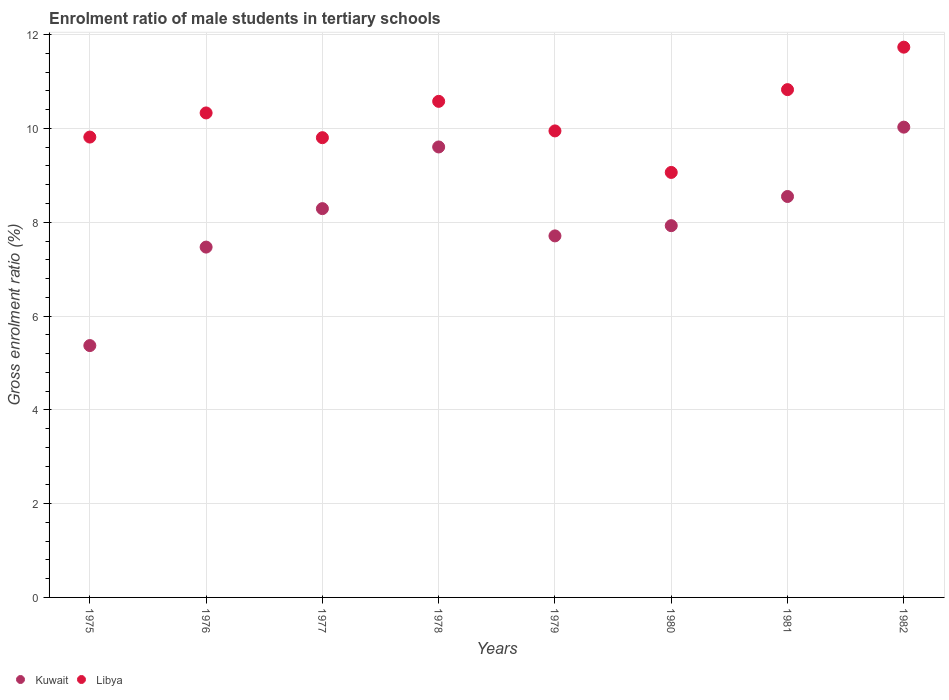How many different coloured dotlines are there?
Your answer should be very brief. 2. Is the number of dotlines equal to the number of legend labels?
Offer a terse response. Yes. What is the enrolment ratio of male students in tertiary schools in Kuwait in 1975?
Offer a terse response. 5.37. Across all years, what is the maximum enrolment ratio of male students in tertiary schools in Libya?
Offer a terse response. 11.73. Across all years, what is the minimum enrolment ratio of male students in tertiary schools in Kuwait?
Give a very brief answer. 5.37. What is the total enrolment ratio of male students in tertiary schools in Libya in the graph?
Offer a very short reply. 82.1. What is the difference between the enrolment ratio of male students in tertiary schools in Kuwait in 1977 and that in 1979?
Your answer should be compact. 0.58. What is the difference between the enrolment ratio of male students in tertiary schools in Libya in 1979 and the enrolment ratio of male students in tertiary schools in Kuwait in 1975?
Make the answer very short. 4.58. What is the average enrolment ratio of male students in tertiary schools in Libya per year?
Offer a very short reply. 10.26. In the year 1976, what is the difference between the enrolment ratio of male students in tertiary schools in Libya and enrolment ratio of male students in tertiary schools in Kuwait?
Offer a very short reply. 2.86. What is the ratio of the enrolment ratio of male students in tertiary schools in Libya in 1979 to that in 1980?
Make the answer very short. 1.1. Is the difference between the enrolment ratio of male students in tertiary schools in Libya in 1977 and 1978 greater than the difference between the enrolment ratio of male students in tertiary schools in Kuwait in 1977 and 1978?
Offer a very short reply. Yes. What is the difference between the highest and the second highest enrolment ratio of male students in tertiary schools in Libya?
Provide a succinct answer. 0.91. What is the difference between the highest and the lowest enrolment ratio of male students in tertiary schools in Libya?
Your answer should be very brief. 2.67. Is the sum of the enrolment ratio of male students in tertiary schools in Kuwait in 1981 and 1982 greater than the maximum enrolment ratio of male students in tertiary schools in Libya across all years?
Provide a short and direct response. Yes. Does the enrolment ratio of male students in tertiary schools in Libya monotonically increase over the years?
Give a very brief answer. No. Is the enrolment ratio of male students in tertiary schools in Kuwait strictly less than the enrolment ratio of male students in tertiary schools in Libya over the years?
Ensure brevity in your answer.  Yes. How many dotlines are there?
Keep it short and to the point. 2. What is the difference between two consecutive major ticks on the Y-axis?
Your response must be concise. 2. Are the values on the major ticks of Y-axis written in scientific E-notation?
Make the answer very short. No. Does the graph contain grids?
Offer a terse response. Yes. Where does the legend appear in the graph?
Keep it short and to the point. Bottom left. How many legend labels are there?
Ensure brevity in your answer.  2. What is the title of the graph?
Ensure brevity in your answer.  Enrolment ratio of male students in tertiary schools. What is the label or title of the Y-axis?
Offer a very short reply. Gross enrolment ratio (%). What is the Gross enrolment ratio (%) in Kuwait in 1975?
Ensure brevity in your answer.  5.37. What is the Gross enrolment ratio (%) in Libya in 1975?
Make the answer very short. 9.82. What is the Gross enrolment ratio (%) of Kuwait in 1976?
Offer a terse response. 7.47. What is the Gross enrolment ratio (%) in Libya in 1976?
Ensure brevity in your answer.  10.33. What is the Gross enrolment ratio (%) in Kuwait in 1977?
Give a very brief answer. 8.29. What is the Gross enrolment ratio (%) of Libya in 1977?
Provide a short and direct response. 9.8. What is the Gross enrolment ratio (%) of Kuwait in 1978?
Offer a terse response. 9.61. What is the Gross enrolment ratio (%) of Libya in 1978?
Give a very brief answer. 10.58. What is the Gross enrolment ratio (%) of Kuwait in 1979?
Provide a short and direct response. 7.71. What is the Gross enrolment ratio (%) of Libya in 1979?
Offer a very short reply. 9.95. What is the Gross enrolment ratio (%) of Kuwait in 1980?
Make the answer very short. 7.93. What is the Gross enrolment ratio (%) in Libya in 1980?
Offer a very short reply. 9.06. What is the Gross enrolment ratio (%) in Kuwait in 1981?
Offer a terse response. 8.55. What is the Gross enrolment ratio (%) in Libya in 1981?
Your answer should be very brief. 10.83. What is the Gross enrolment ratio (%) of Kuwait in 1982?
Your response must be concise. 10.03. What is the Gross enrolment ratio (%) in Libya in 1982?
Offer a terse response. 11.73. Across all years, what is the maximum Gross enrolment ratio (%) of Kuwait?
Give a very brief answer. 10.03. Across all years, what is the maximum Gross enrolment ratio (%) of Libya?
Provide a short and direct response. 11.73. Across all years, what is the minimum Gross enrolment ratio (%) in Kuwait?
Provide a short and direct response. 5.37. Across all years, what is the minimum Gross enrolment ratio (%) of Libya?
Offer a terse response. 9.06. What is the total Gross enrolment ratio (%) in Kuwait in the graph?
Your answer should be very brief. 64.95. What is the total Gross enrolment ratio (%) in Libya in the graph?
Your answer should be compact. 82.1. What is the difference between the Gross enrolment ratio (%) in Kuwait in 1975 and that in 1976?
Offer a terse response. -2.1. What is the difference between the Gross enrolment ratio (%) in Libya in 1975 and that in 1976?
Offer a very short reply. -0.51. What is the difference between the Gross enrolment ratio (%) in Kuwait in 1975 and that in 1977?
Provide a short and direct response. -2.92. What is the difference between the Gross enrolment ratio (%) of Libya in 1975 and that in 1977?
Make the answer very short. 0.01. What is the difference between the Gross enrolment ratio (%) in Kuwait in 1975 and that in 1978?
Give a very brief answer. -4.24. What is the difference between the Gross enrolment ratio (%) of Libya in 1975 and that in 1978?
Keep it short and to the point. -0.76. What is the difference between the Gross enrolment ratio (%) of Kuwait in 1975 and that in 1979?
Provide a succinct answer. -2.34. What is the difference between the Gross enrolment ratio (%) in Libya in 1975 and that in 1979?
Offer a terse response. -0.13. What is the difference between the Gross enrolment ratio (%) of Kuwait in 1975 and that in 1980?
Give a very brief answer. -2.56. What is the difference between the Gross enrolment ratio (%) of Libya in 1975 and that in 1980?
Offer a terse response. 0.75. What is the difference between the Gross enrolment ratio (%) of Kuwait in 1975 and that in 1981?
Ensure brevity in your answer.  -3.18. What is the difference between the Gross enrolment ratio (%) in Libya in 1975 and that in 1981?
Give a very brief answer. -1.01. What is the difference between the Gross enrolment ratio (%) in Kuwait in 1975 and that in 1982?
Keep it short and to the point. -4.66. What is the difference between the Gross enrolment ratio (%) in Libya in 1975 and that in 1982?
Your answer should be compact. -1.92. What is the difference between the Gross enrolment ratio (%) of Kuwait in 1976 and that in 1977?
Provide a short and direct response. -0.82. What is the difference between the Gross enrolment ratio (%) in Libya in 1976 and that in 1977?
Keep it short and to the point. 0.53. What is the difference between the Gross enrolment ratio (%) in Kuwait in 1976 and that in 1978?
Your response must be concise. -2.14. What is the difference between the Gross enrolment ratio (%) in Libya in 1976 and that in 1978?
Keep it short and to the point. -0.25. What is the difference between the Gross enrolment ratio (%) of Kuwait in 1976 and that in 1979?
Your response must be concise. -0.24. What is the difference between the Gross enrolment ratio (%) of Libya in 1976 and that in 1979?
Keep it short and to the point. 0.38. What is the difference between the Gross enrolment ratio (%) in Kuwait in 1976 and that in 1980?
Your answer should be very brief. -0.46. What is the difference between the Gross enrolment ratio (%) of Libya in 1976 and that in 1980?
Provide a short and direct response. 1.27. What is the difference between the Gross enrolment ratio (%) in Kuwait in 1976 and that in 1981?
Your response must be concise. -1.08. What is the difference between the Gross enrolment ratio (%) of Libya in 1976 and that in 1981?
Your answer should be very brief. -0.5. What is the difference between the Gross enrolment ratio (%) in Kuwait in 1976 and that in 1982?
Your answer should be compact. -2.56. What is the difference between the Gross enrolment ratio (%) of Libya in 1976 and that in 1982?
Your response must be concise. -1.4. What is the difference between the Gross enrolment ratio (%) of Kuwait in 1977 and that in 1978?
Offer a terse response. -1.32. What is the difference between the Gross enrolment ratio (%) of Libya in 1977 and that in 1978?
Offer a terse response. -0.77. What is the difference between the Gross enrolment ratio (%) in Kuwait in 1977 and that in 1979?
Offer a very short reply. 0.58. What is the difference between the Gross enrolment ratio (%) of Libya in 1977 and that in 1979?
Provide a short and direct response. -0.14. What is the difference between the Gross enrolment ratio (%) of Kuwait in 1977 and that in 1980?
Make the answer very short. 0.36. What is the difference between the Gross enrolment ratio (%) in Libya in 1977 and that in 1980?
Ensure brevity in your answer.  0.74. What is the difference between the Gross enrolment ratio (%) of Kuwait in 1977 and that in 1981?
Make the answer very short. -0.26. What is the difference between the Gross enrolment ratio (%) in Libya in 1977 and that in 1981?
Ensure brevity in your answer.  -1.02. What is the difference between the Gross enrolment ratio (%) of Kuwait in 1977 and that in 1982?
Give a very brief answer. -1.74. What is the difference between the Gross enrolment ratio (%) in Libya in 1977 and that in 1982?
Your answer should be compact. -1.93. What is the difference between the Gross enrolment ratio (%) in Kuwait in 1978 and that in 1979?
Your response must be concise. 1.9. What is the difference between the Gross enrolment ratio (%) of Libya in 1978 and that in 1979?
Offer a very short reply. 0.63. What is the difference between the Gross enrolment ratio (%) of Kuwait in 1978 and that in 1980?
Your response must be concise. 1.68. What is the difference between the Gross enrolment ratio (%) of Libya in 1978 and that in 1980?
Keep it short and to the point. 1.52. What is the difference between the Gross enrolment ratio (%) of Kuwait in 1978 and that in 1981?
Your answer should be very brief. 1.06. What is the difference between the Gross enrolment ratio (%) in Libya in 1978 and that in 1981?
Ensure brevity in your answer.  -0.25. What is the difference between the Gross enrolment ratio (%) in Kuwait in 1978 and that in 1982?
Offer a very short reply. -0.42. What is the difference between the Gross enrolment ratio (%) in Libya in 1978 and that in 1982?
Provide a short and direct response. -1.16. What is the difference between the Gross enrolment ratio (%) of Kuwait in 1979 and that in 1980?
Your response must be concise. -0.22. What is the difference between the Gross enrolment ratio (%) of Libya in 1979 and that in 1980?
Your answer should be compact. 0.89. What is the difference between the Gross enrolment ratio (%) in Kuwait in 1979 and that in 1981?
Your answer should be compact. -0.84. What is the difference between the Gross enrolment ratio (%) in Libya in 1979 and that in 1981?
Keep it short and to the point. -0.88. What is the difference between the Gross enrolment ratio (%) in Kuwait in 1979 and that in 1982?
Your answer should be compact. -2.32. What is the difference between the Gross enrolment ratio (%) of Libya in 1979 and that in 1982?
Provide a short and direct response. -1.79. What is the difference between the Gross enrolment ratio (%) of Kuwait in 1980 and that in 1981?
Your answer should be very brief. -0.62. What is the difference between the Gross enrolment ratio (%) of Libya in 1980 and that in 1981?
Give a very brief answer. -1.77. What is the difference between the Gross enrolment ratio (%) of Kuwait in 1980 and that in 1982?
Provide a succinct answer. -2.1. What is the difference between the Gross enrolment ratio (%) in Libya in 1980 and that in 1982?
Ensure brevity in your answer.  -2.67. What is the difference between the Gross enrolment ratio (%) in Kuwait in 1981 and that in 1982?
Offer a terse response. -1.48. What is the difference between the Gross enrolment ratio (%) of Libya in 1981 and that in 1982?
Your answer should be very brief. -0.91. What is the difference between the Gross enrolment ratio (%) in Kuwait in 1975 and the Gross enrolment ratio (%) in Libya in 1976?
Your response must be concise. -4.96. What is the difference between the Gross enrolment ratio (%) of Kuwait in 1975 and the Gross enrolment ratio (%) of Libya in 1977?
Ensure brevity in your answer.  -4.43. What is the difference between the Gross enrolment ratio (%) of Kuwait in 1975 and the Gross enrolment ratio (%) of Libya in 1978?
Make the answer very short. -5.21. What is the difference between the Gross enrolment ratio (%) in Kuwait in 1975 and the Gross enrolment ratio (%) in Libya in 1979?
Your response must be concise. -4.58. What is the difference between the Gross enrolment ratio (%) in Kuwait in 1975 and the Gross enrolment ratio (%) in Libya in 1980?
Ensure brevity in your answer.  -3.69. What is the difference between the Gross enrolment ratio (%) of Kuwait in 1975 and the Gross enrolment ratio (%) of Libya in 1981?
Provide a succinct answer. -5.46. What is the difference between the Gross enrolment ratio (%) of Kuwait in 1975 and the Gross enrolment ratio (%) of Libya in 1982?
Make the answer very short. -6.36. What is the difference between the Gross enrolment ratio (%) of Kuwait in 1976 and the Gross enrolment ratio (%) of Libya in 1977?
Your answer should be compact. -2.33. What is the difference between the Gross enrolment ratio (%) of Kuwait in 1976 and the Gross enrolment ratio (%) of Libya in 1978?
Make the answer very short. -3.11. What is the difference between the Gross enrolment ratio (%) in Kuwait in 1976 and the Gross enrolment ratio (%) in Libya in 1979?
Keep it short and to the point. -2.48. What is the difference between the Gross enrolment ratio (%) of Kuwait in 1976 and the Gross enrolment ratio (%) of Libya in 1980?
Offer a terse response. -1.59. What is the difference between the Gross enrolment ratio (%) of Kuwait in 1976 and the Gross enrolment ratio (%) of Libya in 1981?
Make the answer very short. -3.36. What is the difference between the Gross enrolment ratio (%) of Kuwait in 1976 and the Gross enrolment ratio (%) of Libya in 1982?
Keep it short and to the point. -4.26. What is the difference between the Gross enrolment ratio (%) of Kuwait in 1977 and the Gross enrolment ratio (%) of Libya in 1978?
Give a very brief answer. -2.29. What is the difference between the Gross enrolment ratio (%) of Kuwait in 1977 and the Gross enrolment ratio (%) of Libya in 1979?
Keep it short and to the point. -1.66. What is the difference between the Gross enrolment ratio (%) in Kuwait in 1977 and the Gross enrolment ratio (%) in Libya in 1980?
Provide a short and direct response. -0.77. What is the difference between the Gross enrolment ratio (%) of Kuwait in 1977 and the Gross enrolment ratio (%) of Libya in 1981?
Offer a very short reply. -2.54. What is the difference between the Gross enrolment ratio (%) of Kuwait in 1977 and the Gross enrolment ratio (%) of Libya in 1982?
Keep it short and to the point. -3.44. What is the difference between the Gross enrolment ratio (%) in Kuwait in 1978 and the Gross enrolment ratio (%) in Libya in 1979?
Make the answer very short. -0.34. What is the difference between the Gross enrolment ratio (%) in Kuwait in 1978 and the Gross enrolment ratio (%) in Libya in 1980?
Your answer should be compact. 0.54. What is the difference between the Gross enrolment ratio (%) in Kuwait in 1978 and the Gross enrolment ratio (%) in Libya in 1981?
Make the answer very short. -1.22. What is the difference between the Gross enrolment ratio (%) of Kuwait in 1978 and the Gross enrolment ratio (%) of Libya in 1982?
Your answer should be very brief. -2.13. What is the difference between the Gross enrolment ratio (%) of Kuwait in 1979 and the Gross enrolment ratio (%) of Libya in 1980?
Your answer should be compact. -1.35. What is the difference between the Gross enrolment ratio (%) in Kuwait in 1979 and the Gross enrolment ratio (%) in Libya in 1981?
Your answer should be very brief. -3.12. What is the difference between the Gross enrolment ratio (%) of Kuwait in 1979 and the Gross enrolment ratio (%) of Libya in 1982?
Provide a short and direct response. -4.02. What is the difference between the Gross enrolment ratio (%) in Kuwait in 1980 and the Gross enrolment ratio (%) in Libya in 1981?
Offer a terse response. -2.9. What is the difference between the Gross enrolment ratio (%) in Kuwait in 1980 and the Gross enrolment ratio (%) in Libya in 1982?
Offer a terse response. -3.81. What is the difference between the Gross enrolment ratio (%) of Kuwait in 1981 and the Gross enrolment ratio (%) of Libya in 1982?
Make the answer very short. -3.18. What is the average Gross enrolment ratio (%) of Kuwait per year?
Give a very brief answer. 8.12. What is the average Gross enrolment ratio (%) in Libya per year?
Offer a very short reply. 10.26. In the year 1975, what is the difference between the Gross enrolment ratio (%) in Kuwait and Gross enrolment ratio (%) in Libya?
Your response must be concise. -4.45. In the year 1976, what is the difference between the Gross enrolment ratio (%) of Kuwait and Gross enrolment ratio (%) of Libya?
Your response must be concise. -2.86. In the year 1977, what is the difference between the Gross enrolment ratio (%) in Kuwait and Gross enrolment ratio (%) in Libya?
Your answer should be very brief. -1.51. In the year 1978, what is the difference between the Gross enrolment ratio (%) in Kuwait and Gross enrolment ratio (%) in Libya?
Your answer should be very brief. -0.97. In the year 1979, what is the difference between the Gross enrolment ratio (%) in Kuwait and Gross enrolment ratio (%) in Libya?
Ensure brevity in your answer.  -2.24. In the year 1980, what is the difference between the Gross enrolment ratio (%) of Kuwait and Gross enrolment ratio (%) of Libya?
Your answer should be compact. -1.14. In the year 1981, what is the difference between the Gross enrolment ratio (%) of Kuwait and Gross enrolment ratio (%) of Libya?
Provide a succinct answer. -2.28. In the year 1982, what is the difference between the Gross enrolment ratio (%) in Kuwait and Gross enrolment ratio (%) in Libya?
Give a very brief answer. -1.71. What is the ratio of the Gross enrolment ratio (%) in Kuwait in 1975 to that in 1976?
Keep it short and to the point. 0.72. What is the ratio of the Gross enrolment ratio (%) of Libya in 1975 to that in 1976?
Make the answer very short. 0.95. What is the ratio of the Gross enrolment ratio (%) of Kuwait in 1975 to that in 1977?
Ensure brevity in your answer.  0.65. What is the ratio of the Gross enrolment ratio (%) of Kuwait in 1975 to that in 1978?
Offer a terse response. 0.56. What is the ratio of the Gross enrolment ratio (%) in Libya in 1975 to that in 1978?
Your answer should be compact. 0.93. What is the ratio of the Gross enrolment ratio (%) in Kuwait in 1975 to that in 1979?
Keep it short and to the point. 0.7. What is the ratio of the Gross enrolment ratio (%) of Libya in 1975 to that in 1979?
Ensure brevity in your answer.  0.99. What is the ratio of the Gross enrolment ratio (%) in Kuwait in 1975 to that in 1980?
Give a very brief answer. 0.68. What is the ratio of the Gross enrolment ratio (%) of Libya in 1975 to that in 1980?
Your answer should be very brief. 1.08. What is the ratio of the Gross enrolment ratio (%) of Kuwait in 1975 to that in 1981?
Your answer should be very brief. 0.63. What is the ratio of the Gross enrolment ratio (%) of Libya in 1975 to that in 1981?
Offer a terse response. 0.91. What is the ratio of the Gross enrolment ratio (%) of Kuwait in 1975 to that in 1982?
Ensure brevity in your answer.  0.54. What is the ratio of the Gross enrolment ratio (%) in Libya in 1975 to that in 1982?
Your answer should be very brief. 0.84. What is the ratio of the Gross enrolment ratio (%) of Kuwait in 1976 to that in 1977?
Offer a terse response. 0.9. What is the ratio of the Gross enrolment ratio (%) of Libya in 1976 to that in 1977?
Provide a short and direct response. 1.05. What is the ratio of the Gross enrolment ratio (%) of Kuwait in 1976 to that in 1978?
Make the answer very short. 0.78. What is the ratio of the Gross enrolment ratio (%) of Libya in 1976 to that in 1978?
Provide a succinct answer. 0.98. What is the ratio of the Gross enrolment ratio (%) in Kuwait in 1976 to that in 1980?
Offer a very short reply. 0.94. What is the ratio of the Gross enrolment ratio (%) of Libya in 1976 to that in 1980?
Your response must be concise. 1.14. What is the ratio of the Gross enrolment ratio (%) of Kuwait in 1976 to that in 1981?
Your answer should be very brief. 0.87. What is the ratio of the Gross enrolment ratio (%) of Libya in 1976 to that in 1981?
Offer a very short reply. 0.95. What is the ratio of the Gross enrolment ratio (%) in Kuwait in 1976 to that in 1982?
Give a very brief answer. 0.74. What is the ratio of the Gross enrolment ratio (%) in Libya in 1976 to that in 1982?
Ensure brevity in your answer.  0.88. What is the ratio of the Gross enrolment ratio (%) of Kuwait in 1977 to that in 1978?
Your answer should be compact. 0.86. What is the ratio of the Gross enrolment ratio (%) in Libya in 1977 to that in 1978?
Offer a terse response. 0.93. What is the ratio of the Gross enrolment ratio (%) in Kuwait in 1977 to that in 1979?
Offer a terse response. 1.08. What is the ratio of the Gross enrolment ratio (%) of Libya in 1977 to that in 1979?
Your response must be concise. 0.99. What is the ratio of the Gross enrolment ratio (%) in Kuwait in 1977 to that in 1980?
Provide a succinct answer. 1.05. What is the ratio of the Gross enrolment ratio (%) of Libya in 1977 to that in 1980?
Provide a short and direct response. 1.08. What is the ratio of the Gross enrolment ratio (%) of Kuwait in 1977 to that in 1981?
Make the answer very short. 0.97. What is the ratio of the Gross enrolment ratio (%) in Libya in 1977 to that in 1981?
Offer a terse response. 0.91. What is the ratio of the Gross enrolment ratio (%) in Kuwait in 1977 to that in 1982?
Your answer should be compact. 0.83. What is the ratio of the Gross enrolment ratio (%) in Libya in 1977 to that in 1982?
Ensure brevity in your answer.  0.84. What is the ratio of the Gross enrolment ratio (%) of Kuwait in 1978 to that in 1979?
Provide a short and direct response. 1.25. What is the ratio of the Gross enrolment ratio (%) of Libya in 1978 to that in 1979?
Offer a very short reply. 1.06. What is the ratio of the Gross enrolment ratio (%) in Kuwait in 1978 to that in 1980?
Provide a short and direct response. 1.21. What is the ratio of the Gross enrolment ratio (%) in Libya in 1978 to that in 1980?
Give a very brief answer. 1.17. What is the ratio of the Gross enrolment ratio (%) of Kuwait in 1978 to that in 1981?
Provide a succinct answer. 1.12. What is the ratio of the Gross enrolment ratio (%) in Libya in 1978 to that in 1981?
Provide a short and direct response. 0.98. What is the ratio of the Gross enrolment ratio (%) of Kuwait in 1978 to that in 1982?
Offer a very short reply. 0.96. What is the ratio of the Gross enrolment ratio (%) of Libya in 1978 to that in 1982?
Provide a succinct answer. 0.9. What is the ratio of the Gross enrolment ratio (%) of Kuwait in 1979 to that in 1980?
Your answer should be compact. 0.97. What is the ratio of the Gross enrolment ratio (%) in Libya in 1979 to that in 1980?
Make the answer very short. 1.1. What is the ratio of the Gross enrolment ratio (%) in Kuwait in 1979 to that in 1981?
Give a very brief answer. 0.9. What is the ratio of the Gross enrolment ratio (%) in Libya in 1979 to that in 1981?
Your response must be concise. 0.92. What is the ratio of the Gross enrolment ratio (%) in Kuwait in 1979 to that in 1982?
Give a very brief answer. 0.77. What is the ratio of the Gross enrolment ratio (%) in Libya in 1979 to that in 1982?
Offer a terse response. 0.85. What is the ratio of the Gross enrolment ratio (%) of Kuwait in 1980 to that in 1981?
Make the answer very short. 0.93. What is the ratio of the Gross enrolment ratio (%) in Libya in 1980 to that in 1981?
Give a very brief answer. 0.84. What is the ratio of the Gross enrolment ratio (%) in Kuwait in 1980 to that in 1982?
Keep it short and to the point. 0.79. What is the ratio of the Gross enrolment ratio (%) in Libya in 1980 to that in 1982?
Ensure brevity in your answer.  0.77. What is the ratio of the Gross enrolment ratio (%) in Kuwait in 1981 to that in 1982?
Make the answer very short. 0.85. What is the ratio of the Gross enrolment ratio (%) of Libya in 1981 to that in 1982?
Provide a short and direct response. 0.92. What is the difference between the highest and the second highest Gross enrolment ratio (%) in Kuwait?
Give a very brief answer. 0.42. What is the difference between the highest and the second highest Gross enrolment ratio (%) of Libya?
Your answer should be compact. 0.91. What is the difference between the highest and the lowest Gross enrolment ratio (%) in Kuwait?
Give a very brief answer. 4.66. What is the difference between the highest and the lowest Gross enrolment ratio (%) in Libya?
Offer a terse response. 2.67. 